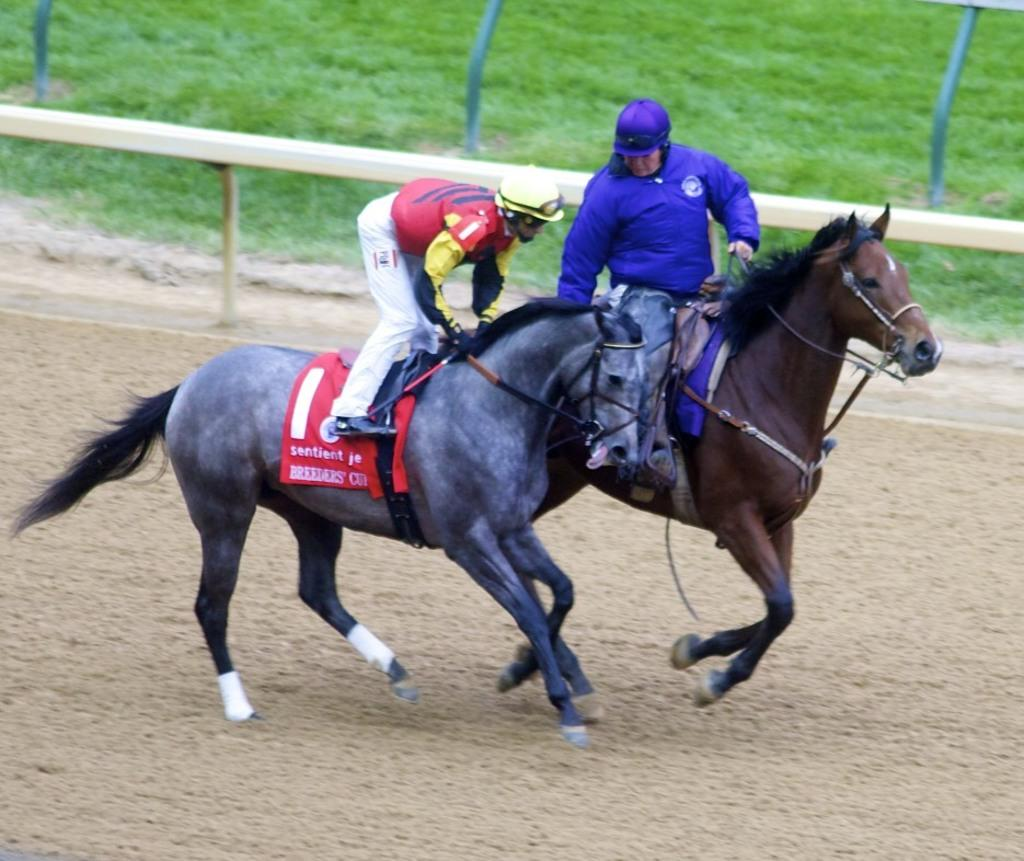How many people are in the image? There are two guys in the image. What are the guys doing in the image? The guys are riding horses. Can you describe the horses in the image? One of the horses is black, and the other horse is brown. What can be seen in the background of the image? There is a grassland in the background of the image. What type of noise can be heard coming from the station in the image? There is no station present in the image, so it's not possible to determine what, if any, noise might be heard. 